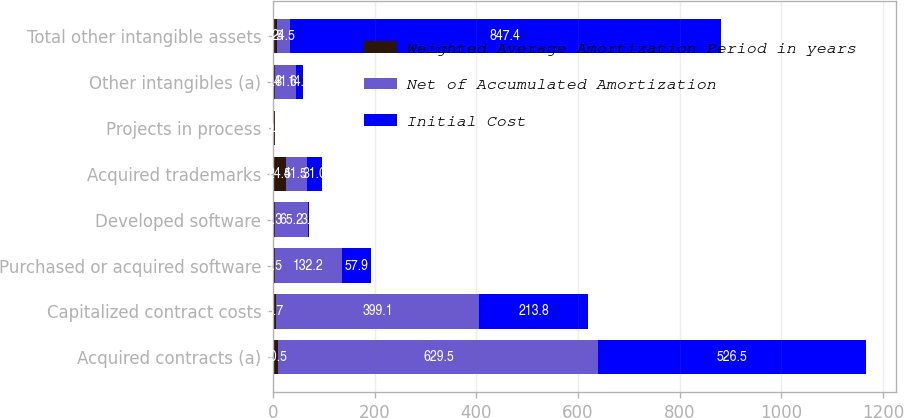<chart> <loc_0><loc_0><loc_500><loc_500><stacked_bar_chart><ecel><fcel>Acquired contracts (a)<fcel>Capitalized contract costs<fcel>Purchased or acquired software<fcel>Developed software<fcel>Acquired trademarks<fcel>Projects in process<fcel>Other intangibles (a)<fcel>Total other intangible assets<nl><fcel>Weighted Average Amortization Period in years<fcel>10.5<fcel>6.7<fcel>3.5<fcel>3.3<fcel>24.5<fcel>3<fcel>3.8<fcel>8.5<nl><fcel>Net of Accumulated Amortization<fcel>629.5<fcel>399.1<fcel>132.2<fcel>65.2<fcel>41.5<fcel>0.8<fcel>41.6<fcel>24.5<nl><fcel>Initial Cost<fcel>526.5<fcel>213.8<fcel>57.9<fcel>3.1<fcel>31<fcel>0.8<fcel>14.3<fcel>847.4<nl></chart> 